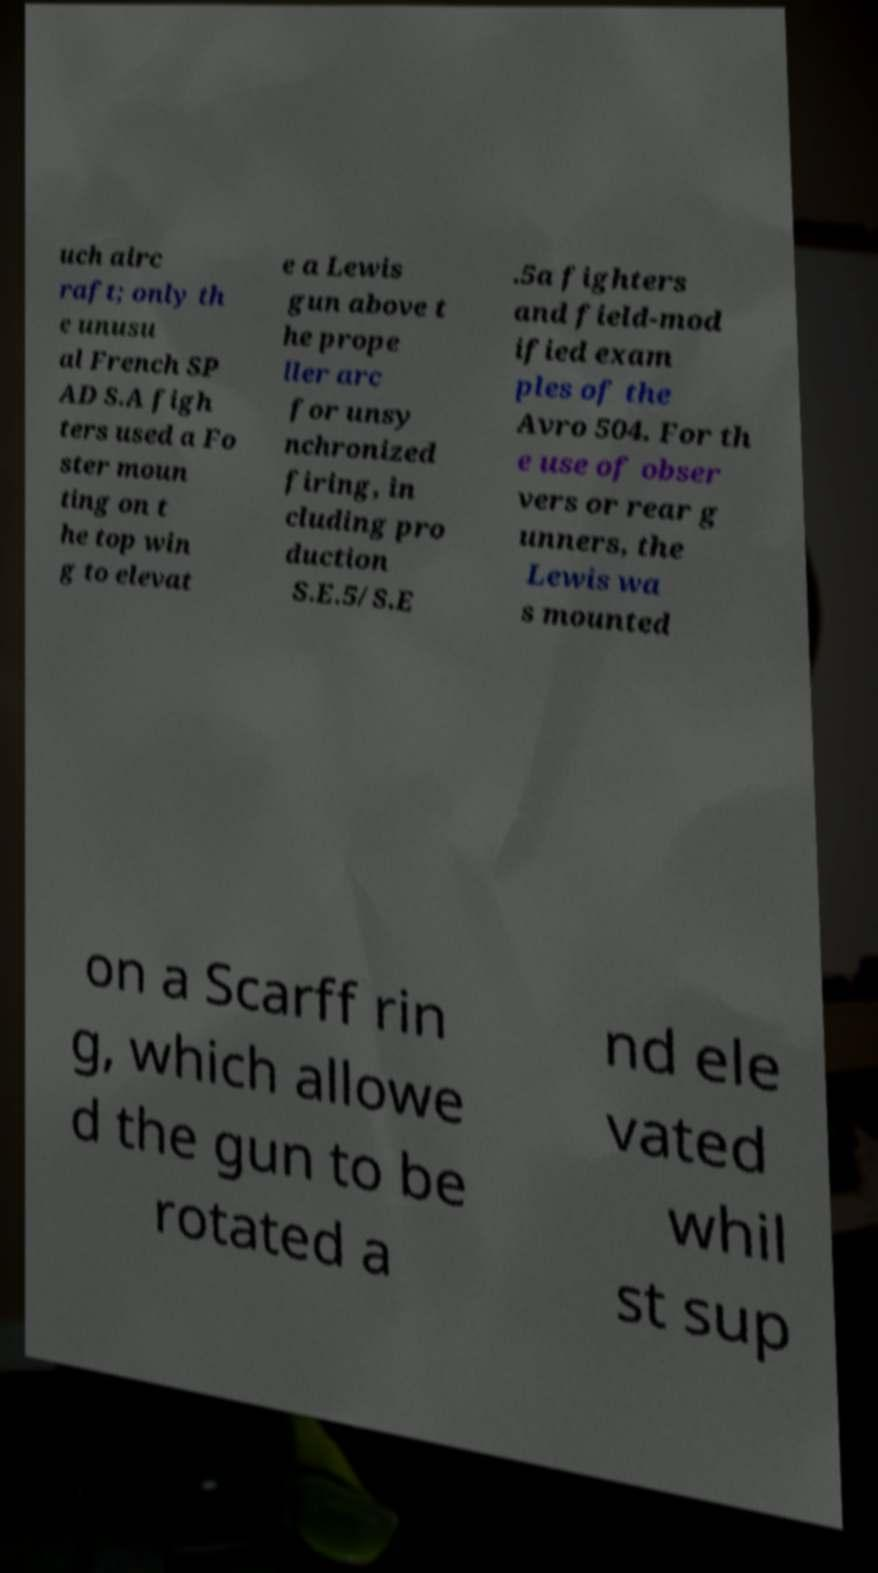Can you read and provide the text displayed in the image?This photo seems to have some interesting text. Can you extract and type it out for me? uch airc raft; only th e unusu al French SP AD S.A figh ters used a Fo ster moun ting on t he top win g to elevat e a Lewis gun above t he prope ller arc for unsy nchronized firing, in cluding pro duction S.E.5/S.E .5a fighters and field-mod ified exam ples of the Avro 504. For th e use of obser vers or rear g unners, the Lewis wa s mounted on a Scarff rin g, which allowe d the gun to be rotated a nd ele vated whil st sup 